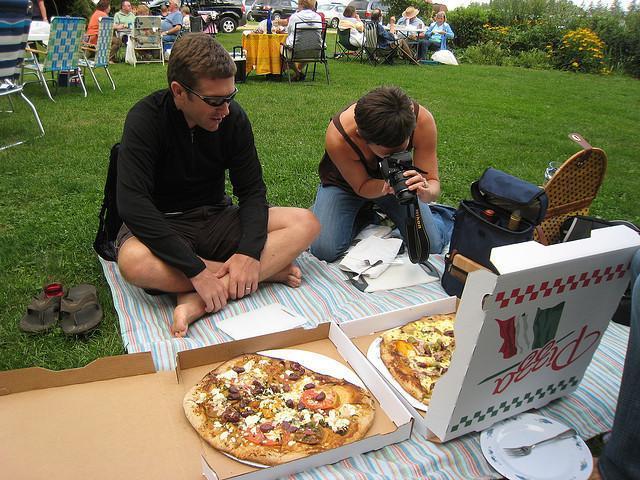How many people are there?
Give a very brief answer. 2. How many chairs are there?
Give a very brief answer. 3. How many pizzas can you see?
Give a very brief answer. 2. How many clocks can you see on the clock tower?
Give a very brief answer. 0. 